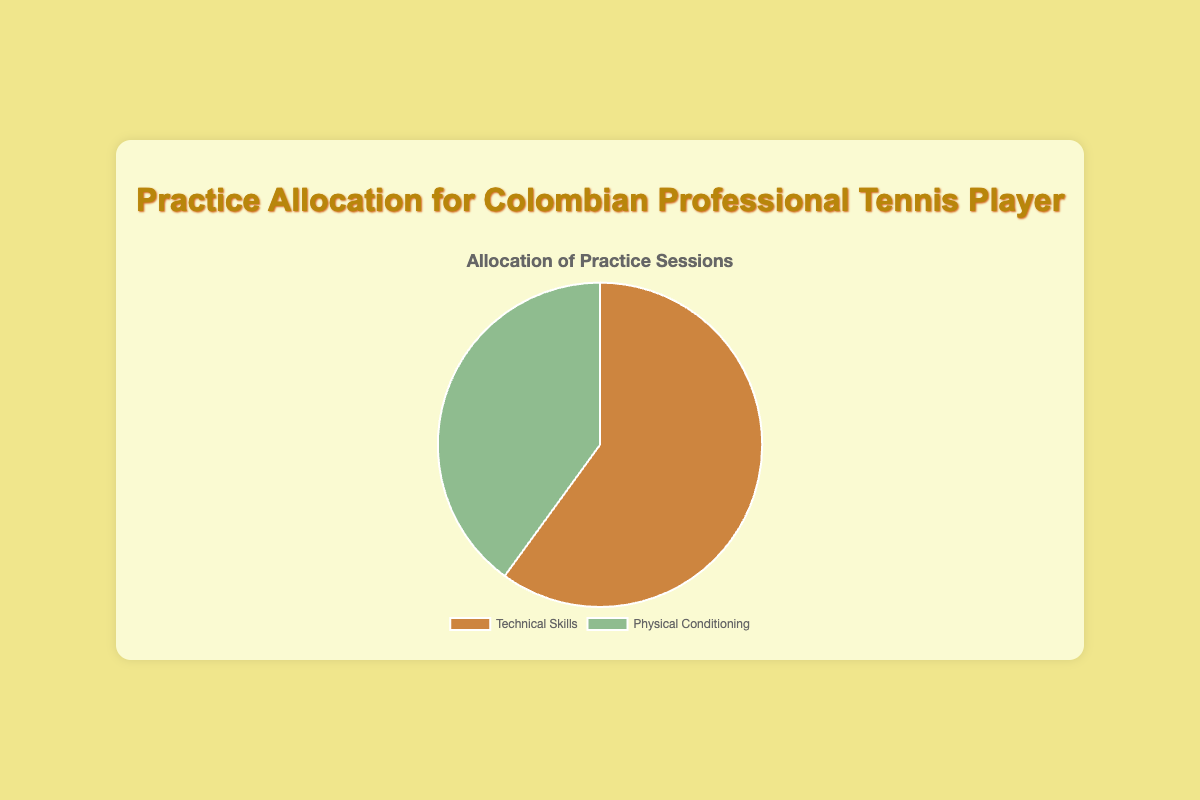What is the percentage of practice sessions allocated to Technical Skills? Referring to the pie chart, we see that the percentage for Technical Skills is explicitly labeled as 60%.
Answer: 60% What is the percentage of practice sessions dedicated to Physical Conditioning? Looking at the pie chart, we can see the percentage for Physical Conditioning is indicated as 40%.
Answer: 40% Which practice session type takes up more time, and by how much? Comparing the two percentages shown in the pie chart – 60% for Technical Skills and 40% for Physical Conditioning – we can see that Technical Skills takes up more time. The difference is 60% - 40% = 20%.
Answer: Technical Skills by 20% If 30 hours are available for practice in a week, how many hours are spent on Technical Skills? To calculate this, multiply the total hours by the percentage allocated to Technical Skills: 30 hours * 60% = 18 hours.
Answer: 18 hours For every hour spent on Physical Conditioning, how many hours are spent on Technical Skills? First, note the percentage allocation: 60% for Technical Skills and 40% for Physical Conditioning. This forms a ratio of 60:40, which simplifies to 3:2. Therefore, for every 2 hours of Physical Conditioning, there are 3 hours of Technical Skills. Simplified further, for every hour of Physical Conditioning, there are 1.5 hours spent on Technical Skills.
Answer: 1.5 hours What colors represent Technical Skills and Physical Conditioning on the pie chart? The visual attributes show that Technical Skills is represented by a brownish color and Physical Conditioning by a greenish color.
Answer: Brown for Technical Skills, Green for Physical Conditioning If the total training hours increase to 40 hours per week, how many additional hours are spent on Physical Conditioning compared to the current 12 hours? Currently, 40% of 30 hours are spent on Physical Conditioning, which is 12 hours. For 40 hours, 40% of 40 hours is 16 hours. The difference is 16 hours - 12 hours = 4 hours.
Answer: 4 hours What is the combined percentage of practice time spent on both Technical Skills and Physical Conditioning? Since the chart is a pie chart, representing a whole, the combined percentage of the two activities should add up to 100%.
Answer: 100% If the focus shifts to a 50-50 distribution, how many extra hours should be allocated to Physical Conditioning if the total training hours per week remain 30? Currently, Physical Conditioning is 40%, resulting in 12 hours out of 30. A shift to 50% would mean 15 hours out of 30. The extra hours needed are 15 hours - 12 hours = 3 hours.
Answer: 3 hours How many more hours per week are spent on Technical Skills compared to Physical Conditioning given the current distribution? Technical Skills are allocated 18 hours per week (60% of 30), and Physical Conditioning is allocated 12 hours (40% of 30). The difference in hours is 18 hours - 12 hours = 6 hours.
Answer: 6 hours 